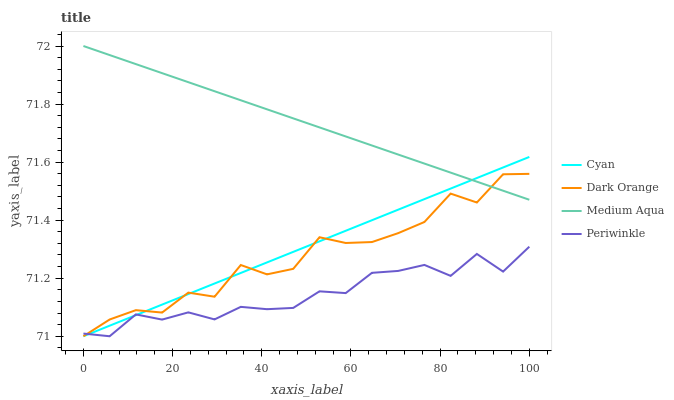Does Medium Aqua have the minimum area under the curve?
Answer yes or no. No. Does Periwinkle have the maximum area under the curve?
Answer yes or no. No. Is Periwinkle the smoothest?
Answer yes or no. No. Is Periwinkle the roughest?
Answer yes or no. No. Does Medium Aqua have the lowest value?
Answer yes or no. No. Does Periwinkle have the highest value?
Answer yes or no. No. Is Periwinkle less than Medium Aqua?
Answer yes or no. Yes. Is Medium Aqua greater than Periwinkle?
Answer yes or no. Yes. Does Periwinkle intersect Medium Aqua?
Answer yes or no. No. 